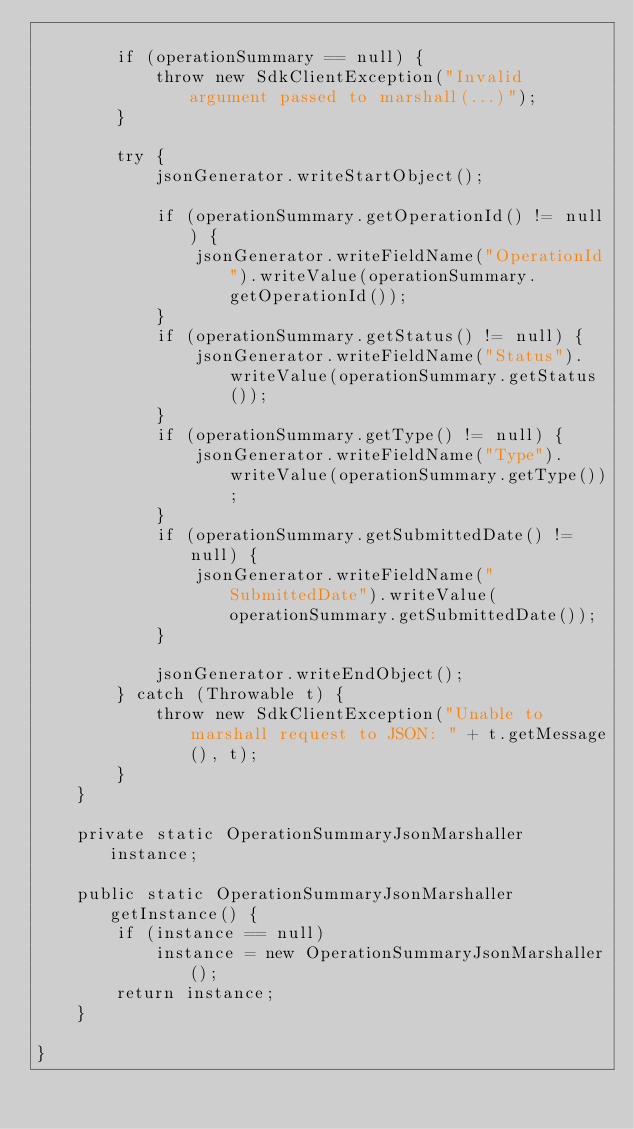Convert code to text. <code><loc_0><loc_0><loc_500><loc_500><_Java_>
        if (operationSummary == null) {
            throw new SdkClientException("Invalid argument passed to marshall(...)");
        }

        try {
            jsonGenerator.writeStartObject();

            if (operationSummary.getOperationId() != null) {
                jsonGenerator.writeFieldName("OperationId").writeValue(operationSummary.getOperationId());
            }
            if (operationSummary.getStatus() != null) {
                jsonGenerator.writeFieldName("Status").writeValue(operationSummary.getStatus());
            }
            if (operationSummary.getType() != null) {
                jsonGenerator.writeFieldName("Type").writeValue(operationSummary.getType());
            }
            if (operationSummary.getSubmittedDate() != null) {
                jsonGenerator.writeFieldName("SubmittedDate").writeValue(operationSummary.getSubmittedDate());
            }

            jsonGenerator.writeEndObject();
        } catch (Throwable t) {
            throw new SdkClientException("Unable to marshall request to JSON: " + t.getMessage(), t);
        }
    }

    private static OperationSummaryJsonMarshaller instance;

    public static OperationSummaryJsonMarshaller getInstance() {
        if (instance == null)
            instance = new OperationSummaryJsonMarshaller();
        return instance;
    }

}
</code> 